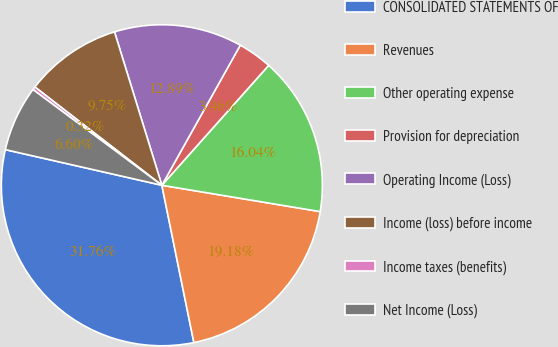Convert chart to OTSL. <chart><loc_0><loc_0><loc_500><loc_500><pie_chart><fcel>CONSOLIDATED STATEMENTS OF<fcel>Revenues<fcel>Other operating expense<fcel>Provision for depreciation<fcel>Operating Income (Loss)<fcel>Income (loss) before income<fcel>Income taxes (benefits)<fcel>Net Income (Loss)<nl><fcel>31.76%<fcel>19.18%<fcel>16.04%<fcel>3.46%<fcel>12.89%<fcel>9.75%<fcel>0.32%<fcel>6.6%<nl></chart> 